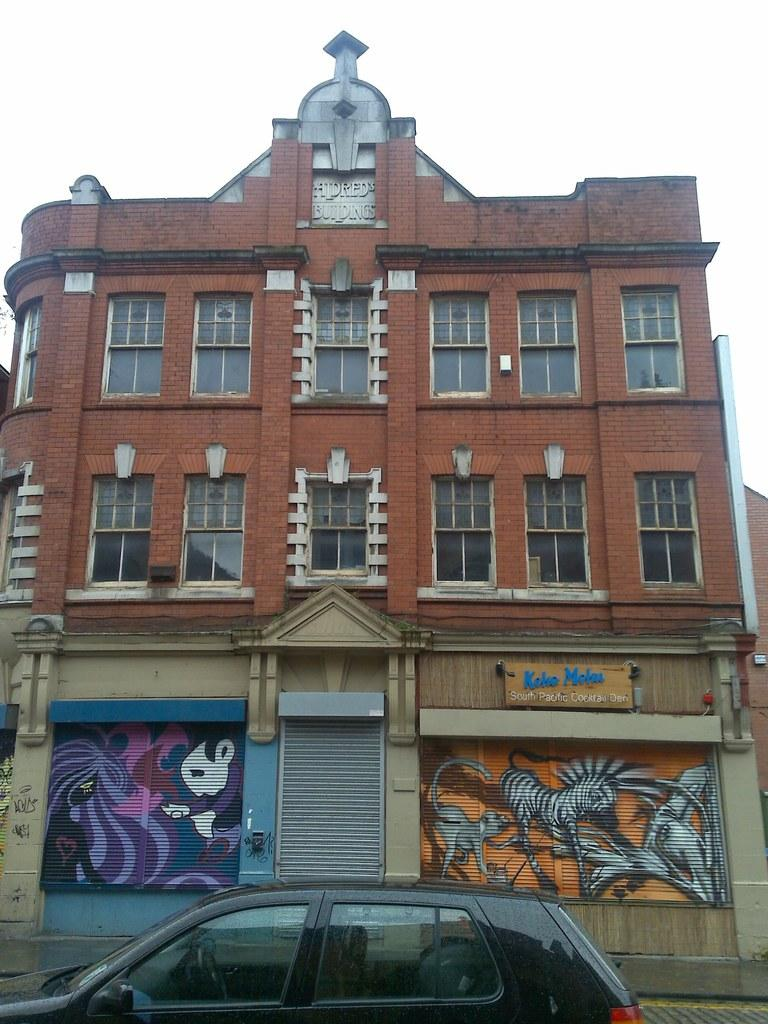What is the main subject in the center of the image? There is a building in the center of the image. What type of vehicle is located at the bottom of the image? There is a black car at the bottom of the image. What can be seen in the background of the image? The sky is visible in the background of the image. What type of farm animals can be seen grazing in the front of the building in the image? There are no farm animals or any indication of a farm in the image. 